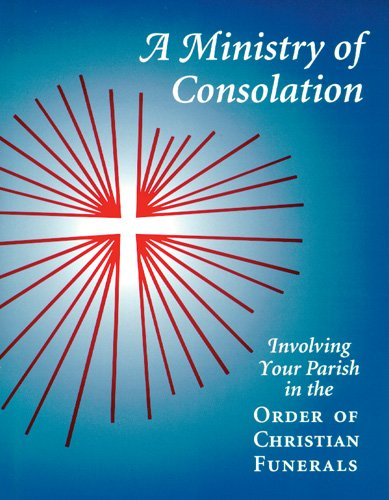How could this book be useful in a parish setting? This book serves as a practical guide for parish leadership, offering strategies to effectively involve the community in the Christian funeral rites, which can provide emotional and spiritual support during times of loss. 